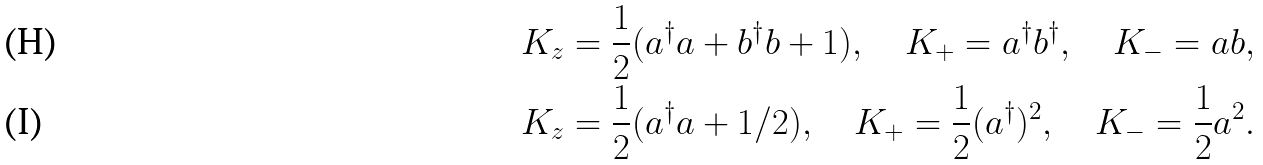<formula> <loc_0><loc_0><loc_500><loc_500>& K _ { z } = \frac { 1 } { 2 } ( a ^ { \dag } a + b ^ { \dag } b + 1 ) , \quad K _ { + } = a ^ { \dag } b ^ { \dag } , \quad K _ { - } = a b , \\ & K _ { z } = \frac { 1 } { 2 } ( a ^ { \dag } a + 1 / 2 ) , \quad K _ { + } = \frac { 1 } { 2 } ( a ^ { \dag } ) ^ { 2 } , \quad K _ { - } = \frac { 1 } { 2 } a ^ { 2 } .</formula> 